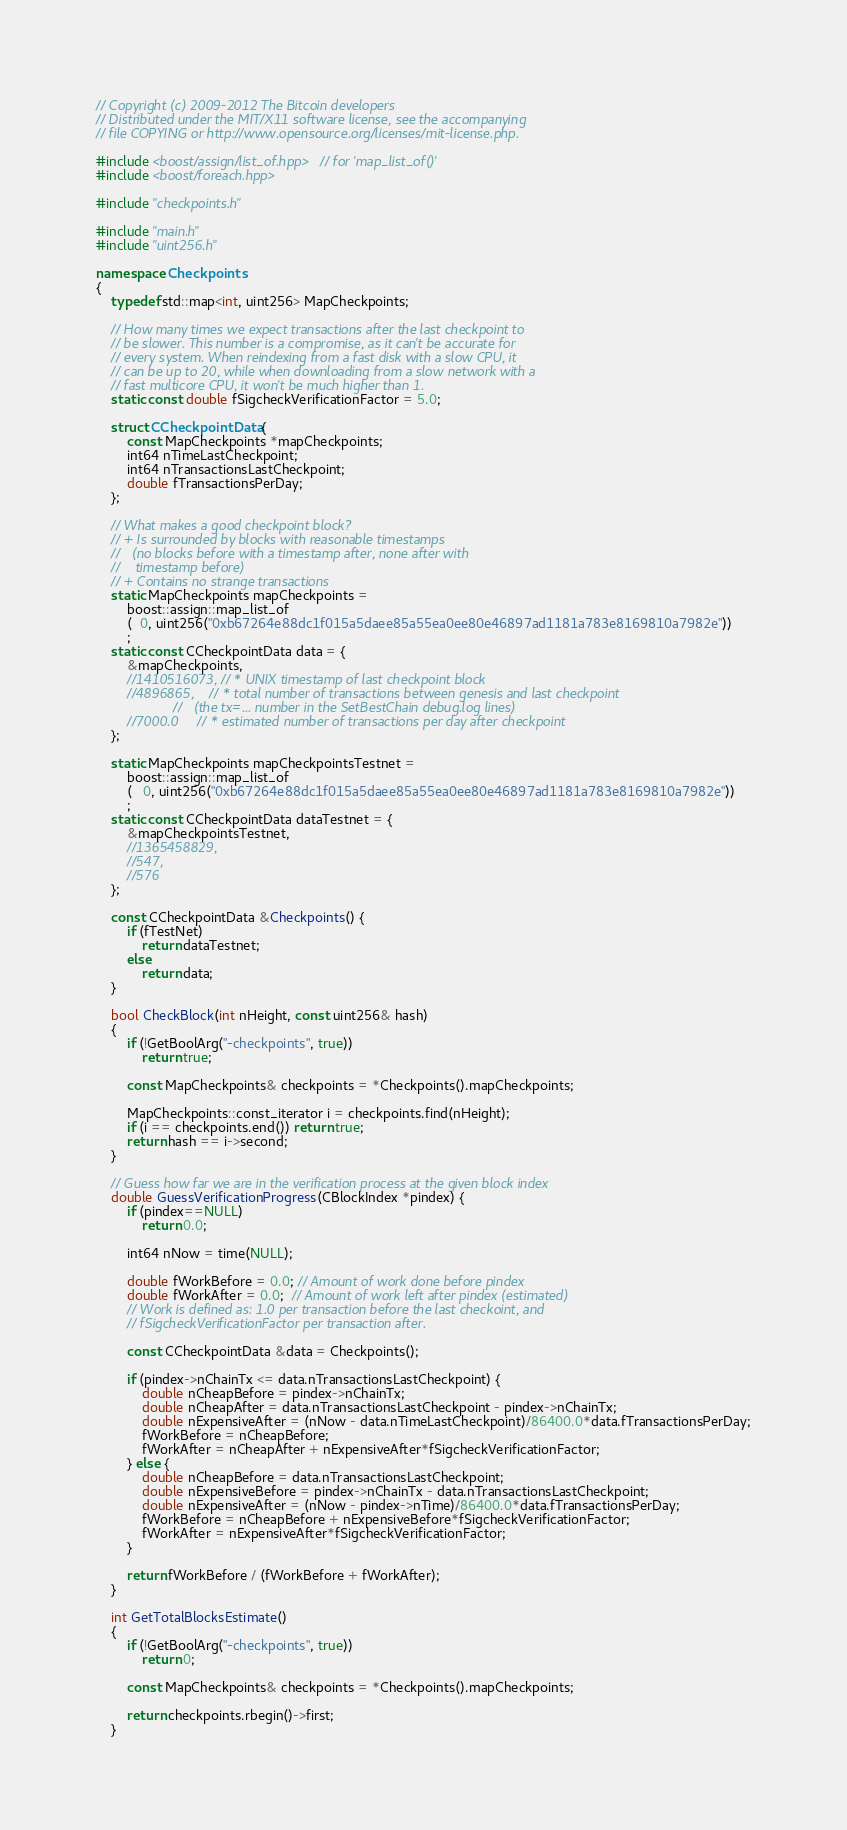Convert code to text. <code><loc_0><loc_0><loc_500><loc_500><_C++_>// Copyright (c) 2009-2012 The Bitcoin developers
// Distributed under the MIT/X11 software license, see the accompanying
// file COPYING or http://www.opensource.org/licenses/mit-license.php.

#include <boost/assign/list_of.hpp> // for 'map_list_of()'
#include <boost/foreach.hpp>

#include "checkpoints.h"

#include "main.h"
#include "uint256.h"

namespace Checkpoints
{
    typedef std::map<int, uint256> MapCheckpoints;

    // How many times we expect transactions after the last checkpoint to
    // be slower. This number is a compromise, as it can't be accurate for
    // every system. When reindexing from a fast disk with a slow CPU, it
    // can be up to 20, while when downloading from a slow network with a
    // fast multicore CPU, it won't be much higher than 1.
    static const double fSigcheckVerificationFactor = 5.0;

    struct CCheckpointData {
        const MapCheckpoints *mapCheckpoints;
        int64 nTimeLastCheckpoint;
        int64 nTransactionsLastCheckpoint;
        double fTransactionsPerDay;
    };

    // What makes a good checkpoint block?
    // + Is surrounded by blocks with reasonable timestamps
    //   (no blocks before with a timestamp after, none after with
    //    timestamp before)
    // + Contains no strange transactions
    static MapCheckpoints mapCheckpoints =
        boost::assign::map_list_of
        (  0, uint256("0xb67264e88dc1f015a5daee85a55ea0ee80e46897ad1181a783e8169810a7982e"))
        ;
    static const CCheckpointData data = {
        &mapCheckpoints,
        //1410516073, // * UNIX timestamp of last checkpoint block
        //4896865,    // * total number of transactions between genesis and last checkpoint
                    //   (the tx=... number in the SetBestChain debug.log lines)
        //7000.0     // * estimated number of transactions per day after checkpoint
    };

    static MapCheckpoints mapCheckpointsTestnet =
        boost::assign::map_list_of
        (   0, uint256("0xb67264e88dc1f015a5daee85a55ea0ee80e46897ad1181a783e8169810a7982e"))
        ;
    static const CCheckpointData dataTestnet = {
        &mapCheckpointsTestnet,
        //1365458829,
        //547,
        //576
    };

    const CCheckpointData &Checkpoints() {
        if (fTestNet)
            return dataTestnet;
        else
            return data;
    }

    bool CheckBlock(int nHeight, const uint256& hash)
    {
        if (!GetBoolArg("-checkpoints", true))
            return true;

        const MapCheckpoints& checkpoints = *Checkpoints().mapCheckpoints;

        MapCheckpoints::const_iterator i = checkpoints.find(nHeight);
        if (i == checkpoints.end()) return true;
        return hash == i->second;
    }

    // Guess how far we are in the verification process at the given block index
    double GuessVerificationProgress(CBlockIndex *pindex) {
        if (pindex==NULL)
            return 0.0;

        int64 nNow = time(NULL);

        double fWorkBefore = 0.0; // Amount of work done before pindex
        double fWorkAfter = 0.0;  // Amount of work left after pindex (estimated)
        // Work is defined as: 1.0 per transaction before the last checkoint, and
        // fSigcheckVerificationFactor per transaction after.

        const CCheckpointData &data = Checkpoints();

        if (pindex->nChainTx <= data.nTransactionsLastCheckpoint) {
            double nCheapBefore = pindex->nChainTx;
            double nCheapAfter = data.nTransactionsLastCheckpoint - pindex->nChainTx;
            double nExpensiveAfter = (nNow - data.nTimeLastCheckpoint)/86400.0*data.fTransactionsPerDay;
            fWorkBefore = nCheapBefore;
            fWorkAfter = nCheapAfter + nExpensiveAfter*fSigcheckVerificationFactor;
        } else {
            double nCheapBefore = data.nTransactionsLastCheckpoint;
            double nExpensiveBefore = pindex->nChainTx - data.nTransactionsLastCheckpoint;
            double nExpensiveAfter = (nNow - pindex->nTime)/86400.0*data.fTransactionsPerDay;
            fWorkBefore = nCheapBefore + nExpensiveBefore*fSigcheckVerificationFactor;
            fWorkAfter = nExpensiveAfter*fSigcheckVerificationFactor;
        }

        return fWorkBefore / (fWorkBefore + fWorkAfter);
    }

    int GetTotalBlocksEstimate()
    {
        if (!GetBoolArg("-checkpoints", true))
            return 0;

        const MapCheckpoints& checkpoints = *Checkpoints().mapCheckpoints;

        return checkpoints.rbegin()->first;
    }
</code> 